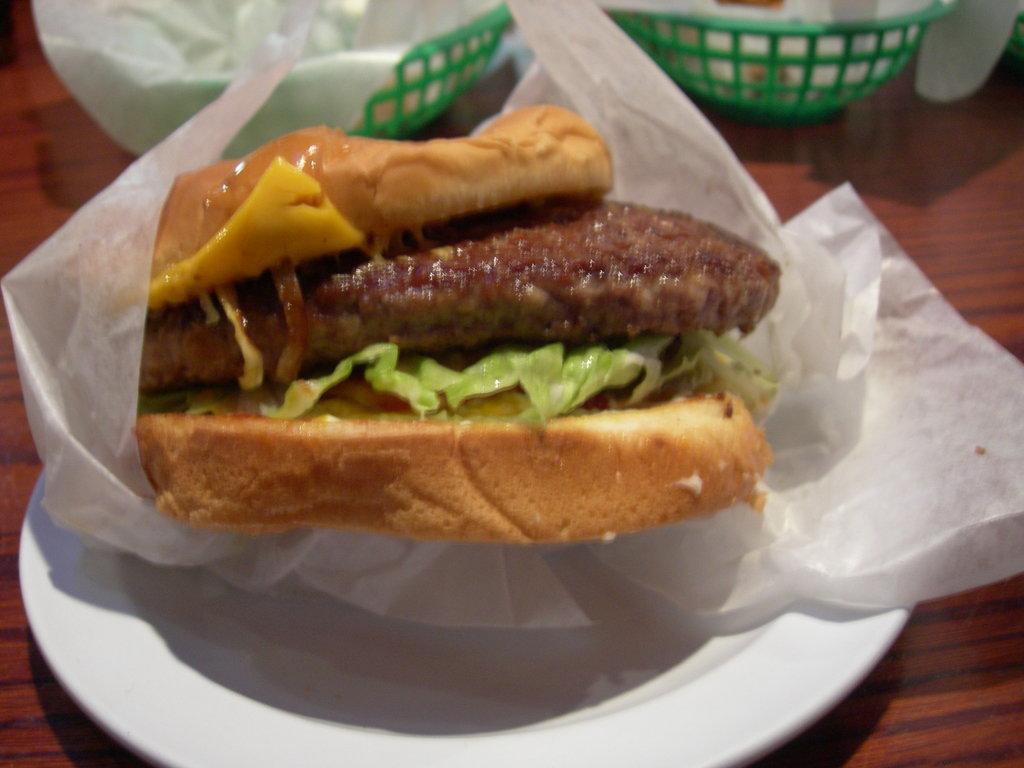Can you describe this image briefly? In this image we can see the food item in a plate and there are some other objects on the table. 